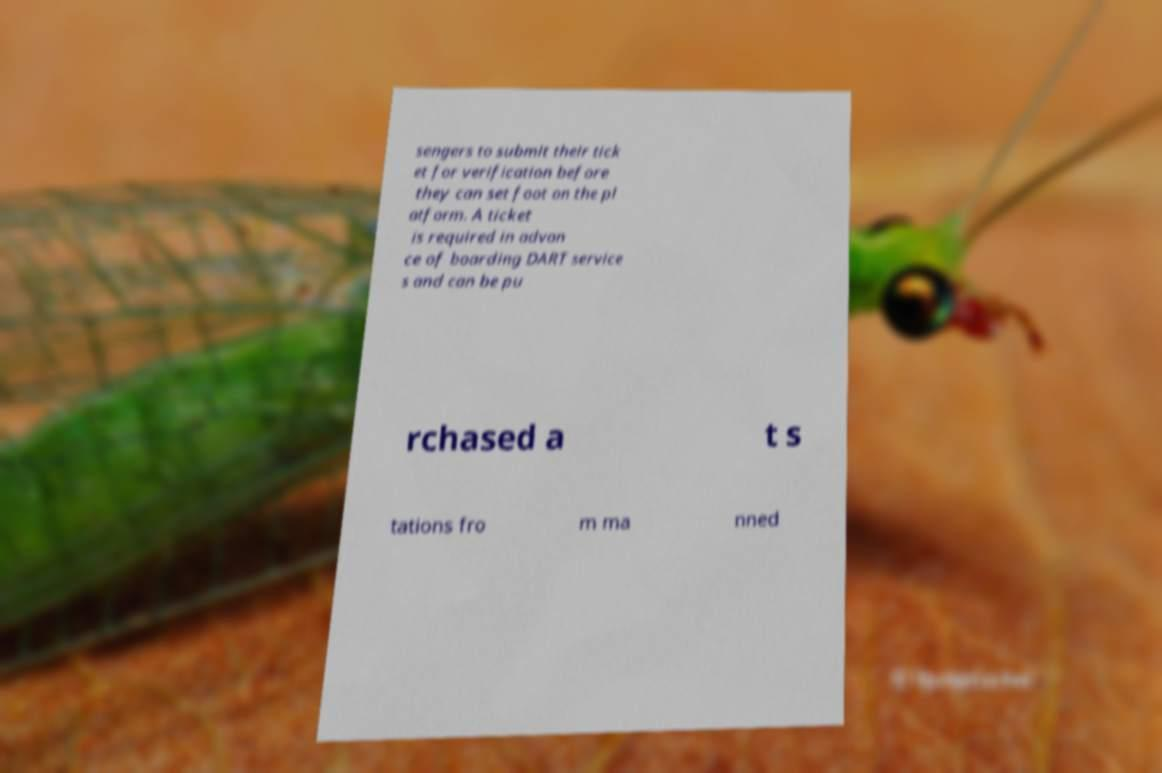Please read and relay the text visible in this image. What does it say? sengers to submit their tick et for verification before they can set foot on the pl atform. A ticket is required in advan ce of boarding DART service s and can be pu rchased a t s tations fro m ma nned 